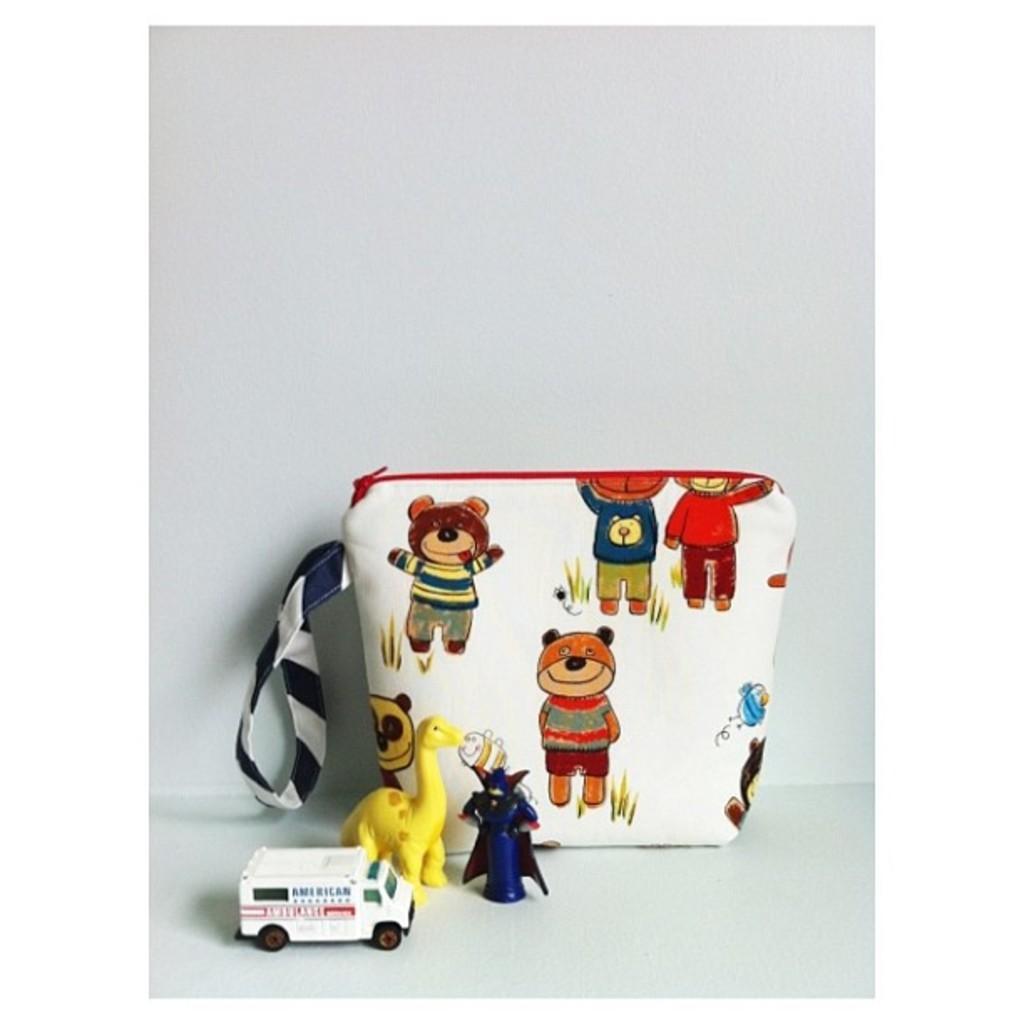How would you summarize this image in a sentence or two? At the bottom of the image on the surface there are toys and also there is a bag with images on it. And there is a white background. 